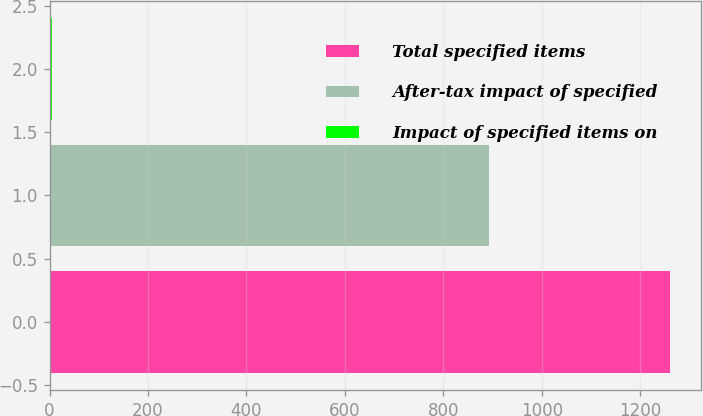Convert chart to OTSL. <chart><loc_0><loc_0><loc_500><loc_500><bar_chart><fcel>Total specified items<fcel>After-tax impact of specified<fcel>Impact of specified items on<nl><fcel>1261<fcel>892<fcel>4.1<nl></chart> 